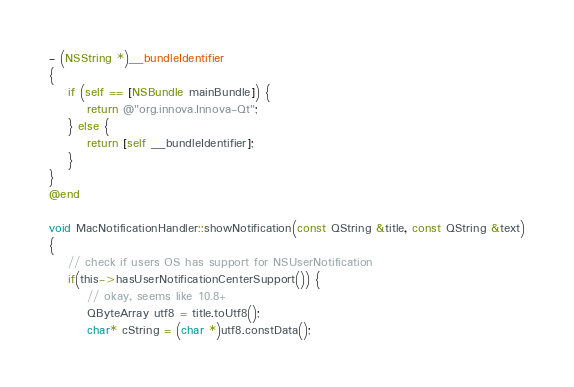Convert code to text. <code><loc_0><loc_0><loc_500><loc_500><_ObjectiveC_>- (NSString *)__bundleIdentifier
{
    if (self == [NSBundle mainBundle]) {
        return @"org.innova.Innova-Qt";
    } else {
        return [self __bundleIdentifier];
    }
}
@end

void MacNotificationHandler::showNotification(const QString &title, const QString &text)
{
    // check if users OS has support for NSUserNotification
    if(this->hasUserNotificationCenterSupport()) {
        // okay, seems like 10.8+
        QByteArray utf8 = title.toUtf8();
        char* cString = (char *)utf8.constData();</code> 